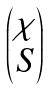<formula> <loc_0><loc_0><loc_500><loc_500>\begin{pmatrix} \chi \\ S \end{pmatrix}</formula> 